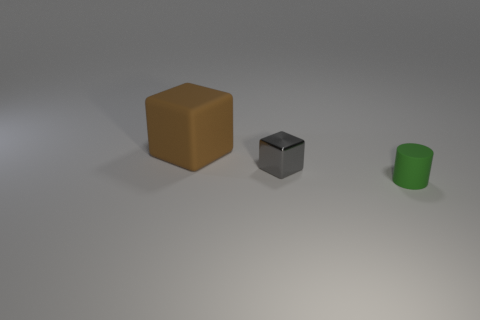There is a matte object to the right of the big cube; is its size the same as the block that is right of the large brown rubber object?
Your response must be concise. Yes. What is the material of the object that is both behind the green object and in front of the big brown matte cube?
Offer a terse response. Metal. How many other things are there of the same size as the gray thing?
Provide a succinct answer. 1. There is a block right of the brown matte cube; what is its material?
Make the answer very short. Metal. Is the shape of the small green object the same as the brown rubber object?
Offer a terse response. No. What number of other objects are the same shape as the small gray object?
Your response must be concise. 1. What color is the tiny thing that is to the right of the tiny shiny thing?
Ensure brevity in your answer.  Green. Do the gray block and the rubber block have the same size?
Offer a very short reply. No. What is the material of the block that is right of the matte thing behind the small green thing?
Provide a succinct answer. Metal. How many rubber objects are the same color as the cylinder?
Give a very brief answer. 0. 